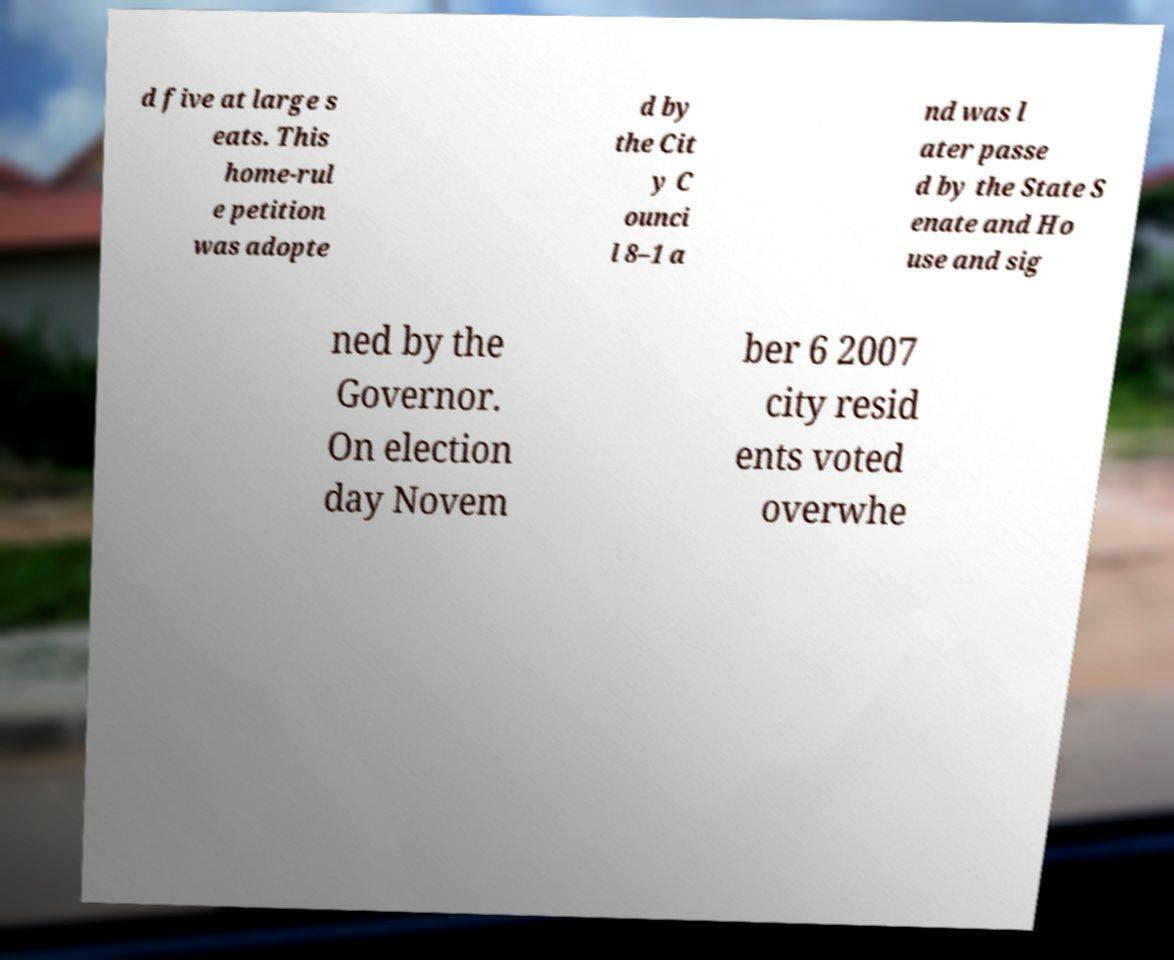Could you extract and type out the text from this image? d five at large s eats. This home-rul e petition was adopte d by the Cit y C ounci l 8–1 a nd was l ater passe d by the State S enate and Ho use and sig ned by the Governor. On election day Novem ber 6 2007 city resid ents voted overwhe 